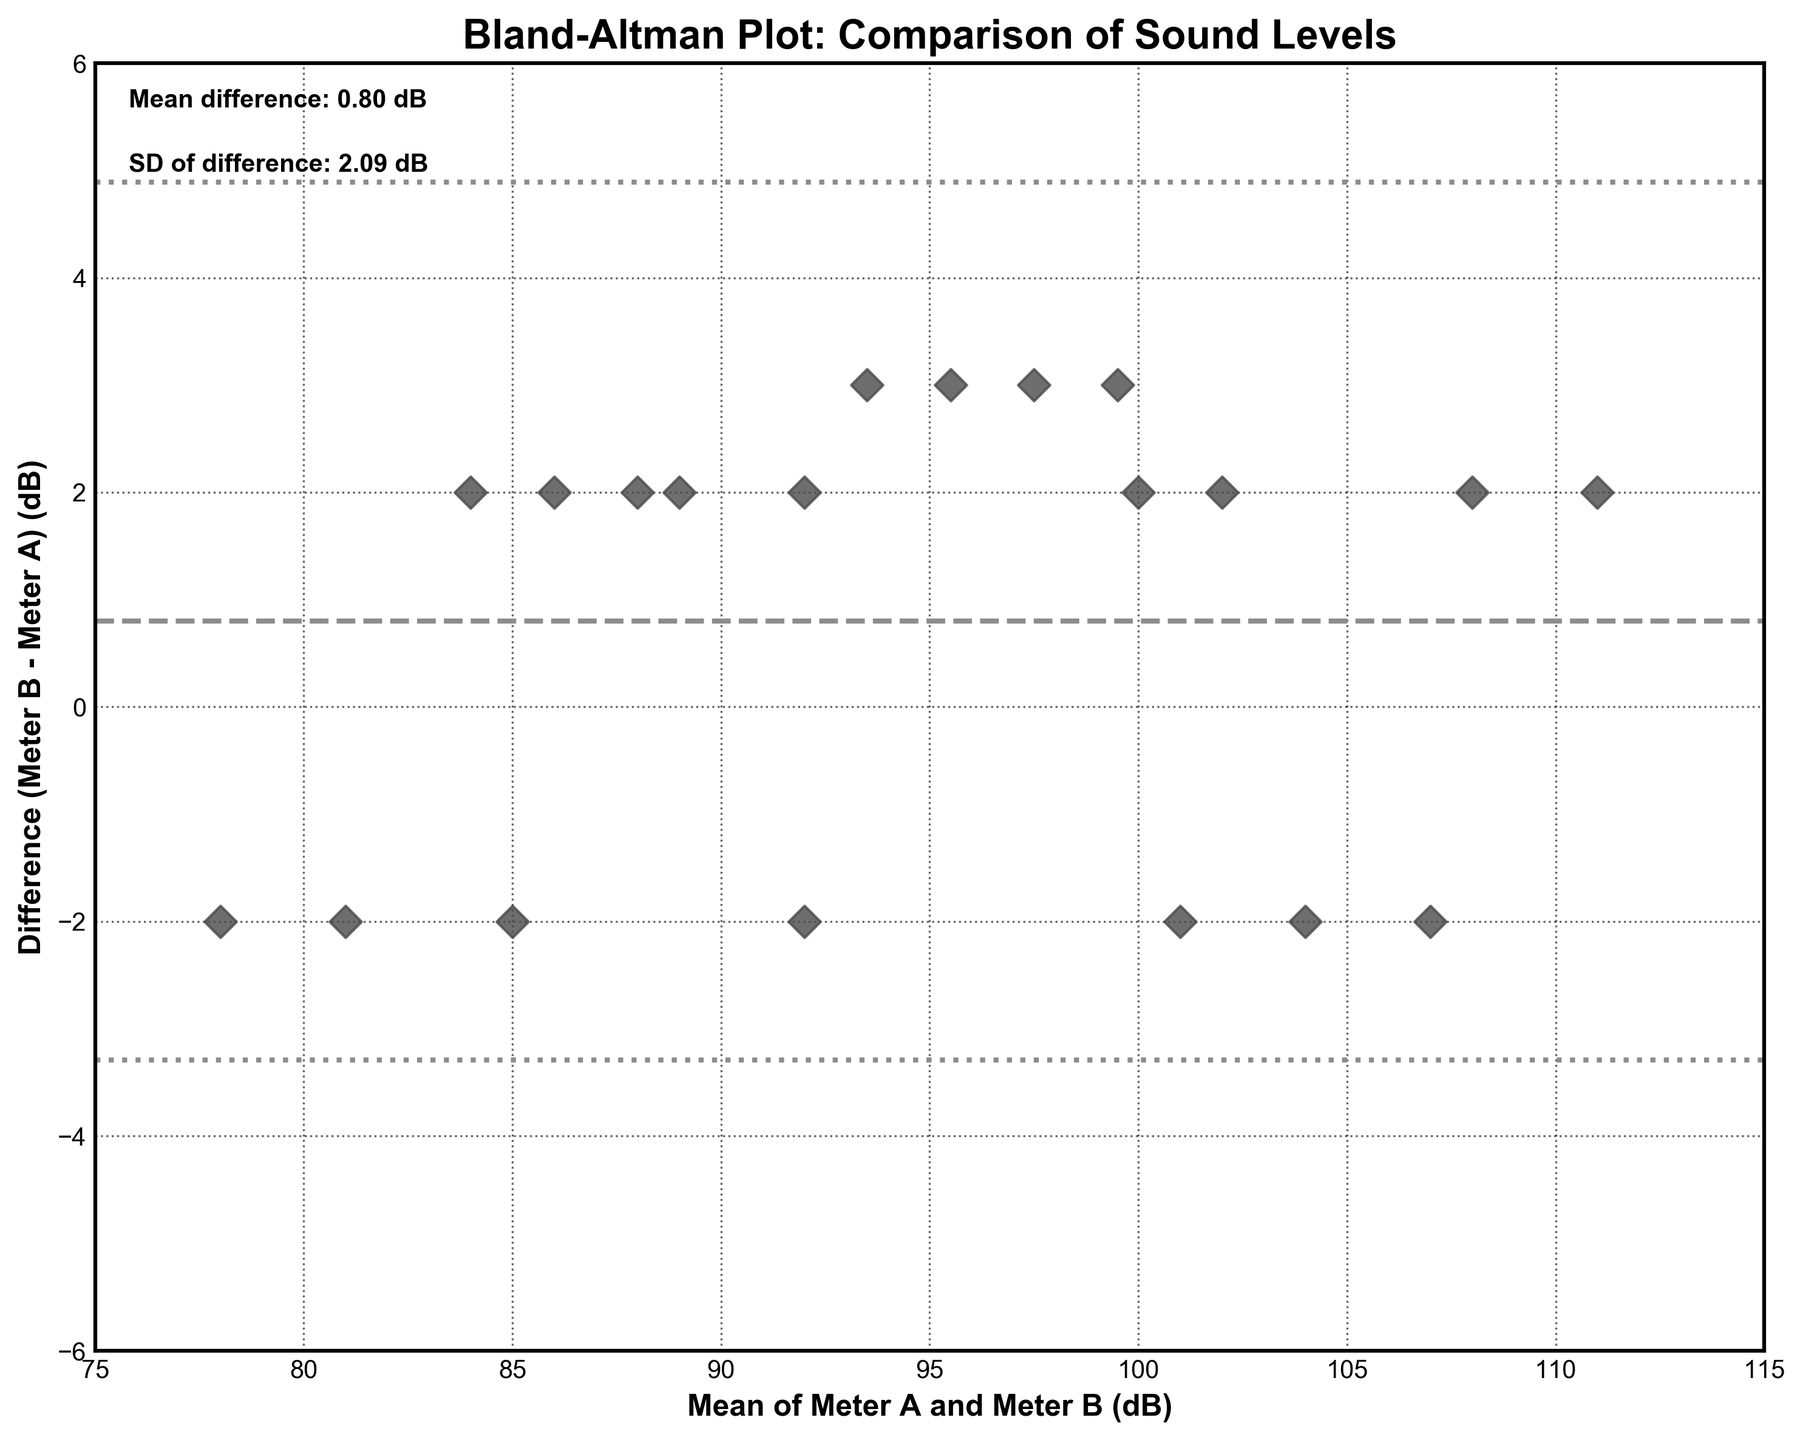How many data points are shown in the plot? By counting the number of points scattered on the plot, we can determine the total number of data points.
Answer: 20 What is the title of the plot? The title is written at the top center of the plot.
Answer: Bland-Altman Plot: Comparison of Sound Levels What does the x-axis represent? The label on the x-axis provides this information.
Answer: Mean of Meter A and Meter B (dB) What is the mean difference between Meter A and Meter B? The mean difference is explicitly mentioned near the top left of the plot.
Answer: 0.85 dB What is the maximum value on the x-axis? The x-axis has tick marks indicating its range. The maximum value can be seen at the end of the axis.
Answer: 115 What is the standard deviation of the difference between Meter A and Meter B? The standard deviation is explicitly written near the top left of the plot.
Answer: 1.84 dB What are the values of the limits of agreement? The limits of agreement are determined by plus and minus 1.96 times the standard deviation from the mean difference. Find these lines on the plot.
Answer: 4.48, -2.78 Is there a point where the maximum positive difference is found? Look for the point with the highest value along the y-axis, and then check its x-coordinate.
Answer: Yes Do most data points fall within the limits of agreement? Observe the distribution of the data points relative to the limits of agreement lines.
Answer: Yes What does it mean if the points on the Bland-Altman plot are close to zero on the y-axis? Interpret the significance of points located near the zero line in terms of measurement differences.
Answer: Indicates good agreement 